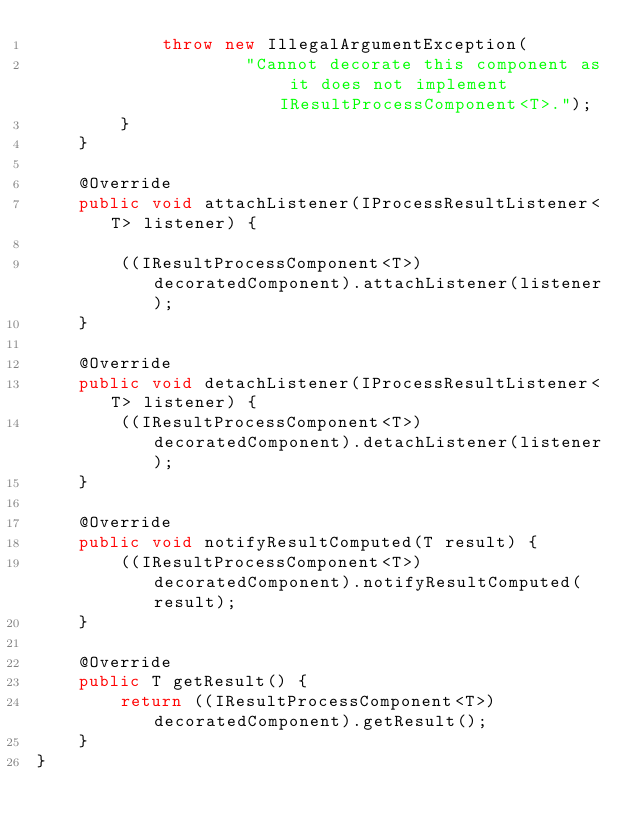Convert code to text. <code><loc_0><loc_0><loc_500><loc_500><_Java_>			throw new IllegalArgumentException(
					"Cannot decorate this component as it does not implement IResultProcessComponent<T>.");
		}
	}

	@Override
	public void attachListener(IProcessResultListener<T> listener) {

		((IResultProcessComponent<T>) decoratedComponent).attachListener(listener);
	}

	@Override
	public void detachListener(IProcessResultListener<T> listener) {
		((IResultProcessComponent<T>) decoratedComponent).detachListener(listener);
	}

	@Override
	public void notifyResultComputed(T result) {
		((IResultProcessComponent<T>) decoratedComponent).notifyResultComputed(result);
	}

	@Override
	public T getResult() {
		return ((IResultProcessComponent<T>) decoratedComponent).getResult();
	}
}
</code> 